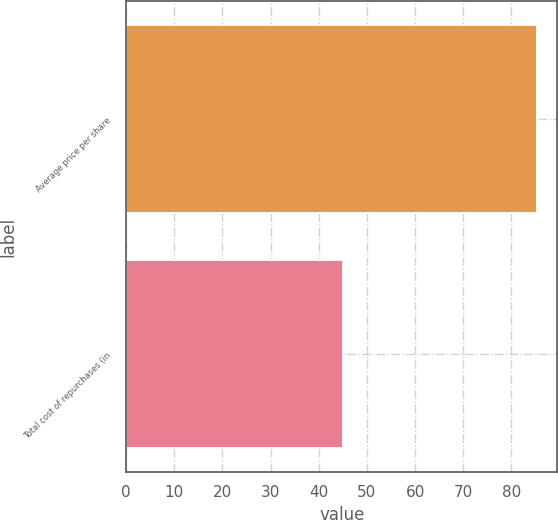<chart> <loc_0><loc_0><loc_500><loc_500><bar_chart><fcel>Average price per share<fcel>Total cost of repurchases (in<nl><fcel>85.27<fcel>45<nl></chart> 